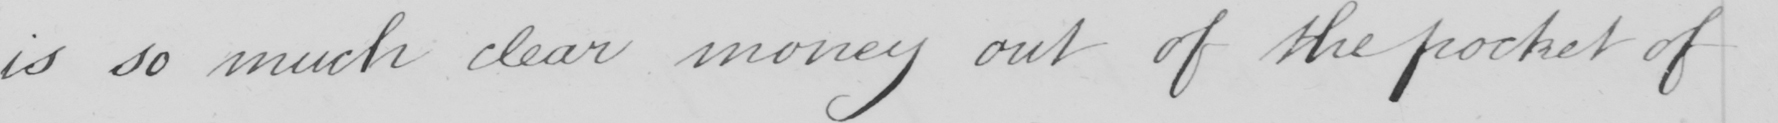Please provide the text content of this handwritten line. is so much clear money out of the pocket of 